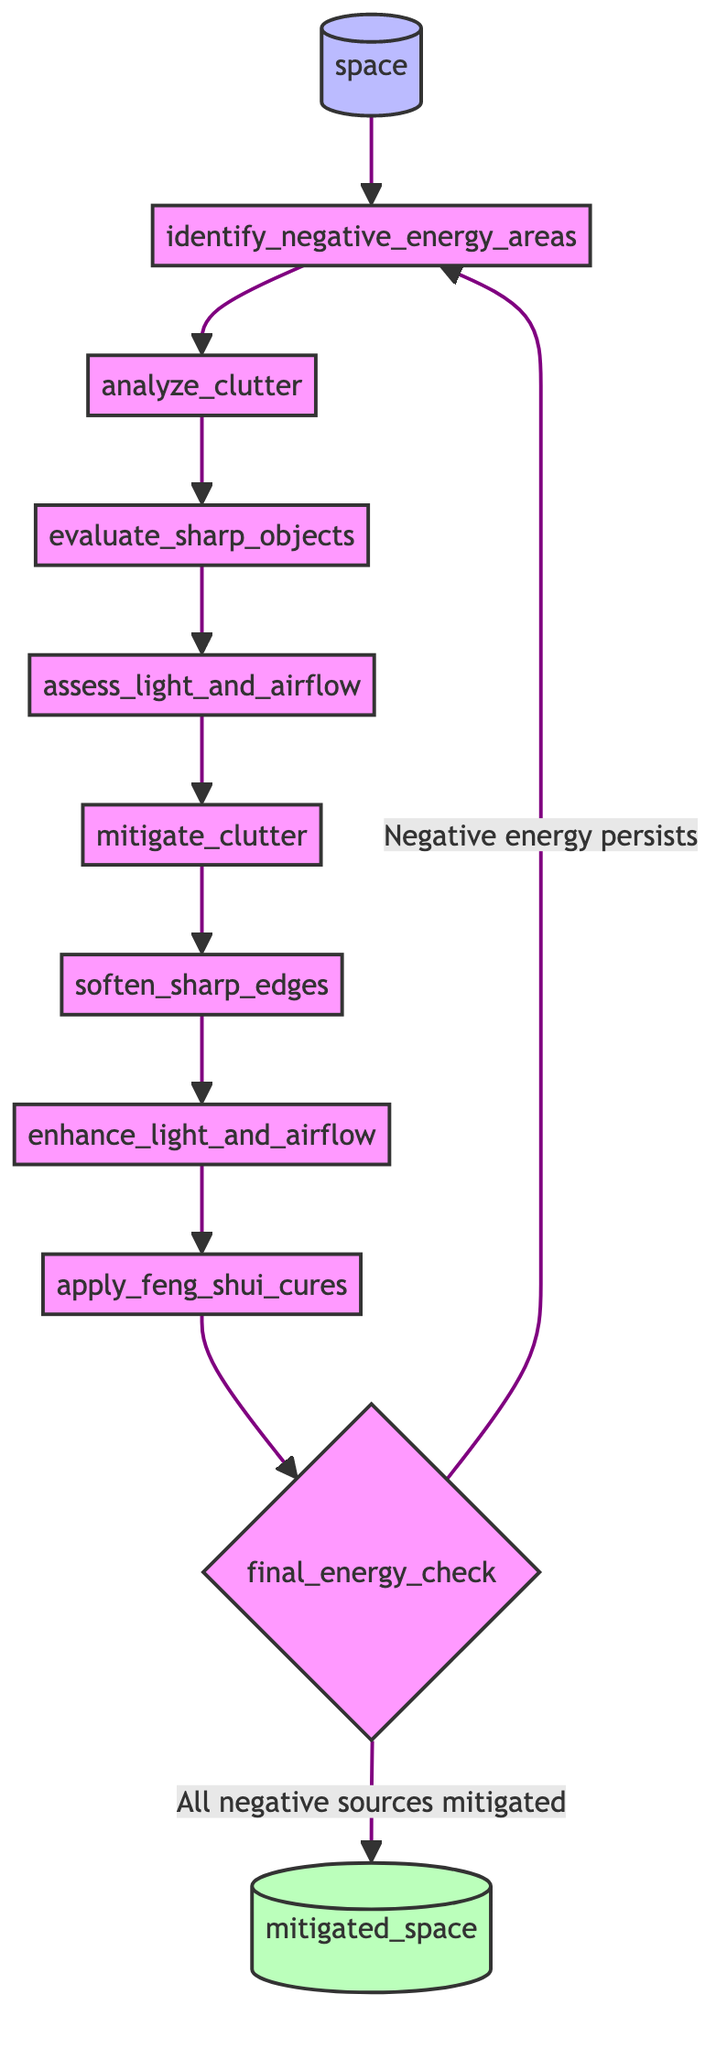What's the first step in the function? The first step in the function is "identify_negative_energy_areas," which surveys the space to identify negative energy sources.
Answer: identify_negative_energy_areas How many steps are there in the flowchart? The flowchart consists of a total of 10 steps from identifying negative energy areas to the final energy check.
Answer: 10 What comes after "assess_light_and_airflow"? The next step after "assess_light_and_airflow" is "mitigate_clutter."
Answer: mitigate_clutter What happens if negative energy persists during the final energy check? If negative energy persists during the final energy check, the flow returns to "identify_negative_energy_areas" to reassess the situation.
Answer: identify_negative_energy_areas What are the last two steps before reaching the output? The last two steps before reaching the output are "apply_feng_shui_cures" and "final_energy_check."
Answer: apply_feng_shui_cures and final_energy_check Which step involves removing clutter? The step that involves removing clutter is "mitigate_clutter."
Answer: mitigate_clutter How many outputs are there from this function? There is one output from this function, which is "mitigated_space."
Answer: 1 What is the purpose of the "final_energy_check" step? The purpose of the "final_energy_check" step is to ensure that all negative sources have been mitigated effectively.
Answer: ensure all negative sources have been mitigated effectively What action must be taken if sharp edges are identified? If sharp edges are identified, the action to take is to "soften_sharp_edges."
Answer: soften_sharp_edges 